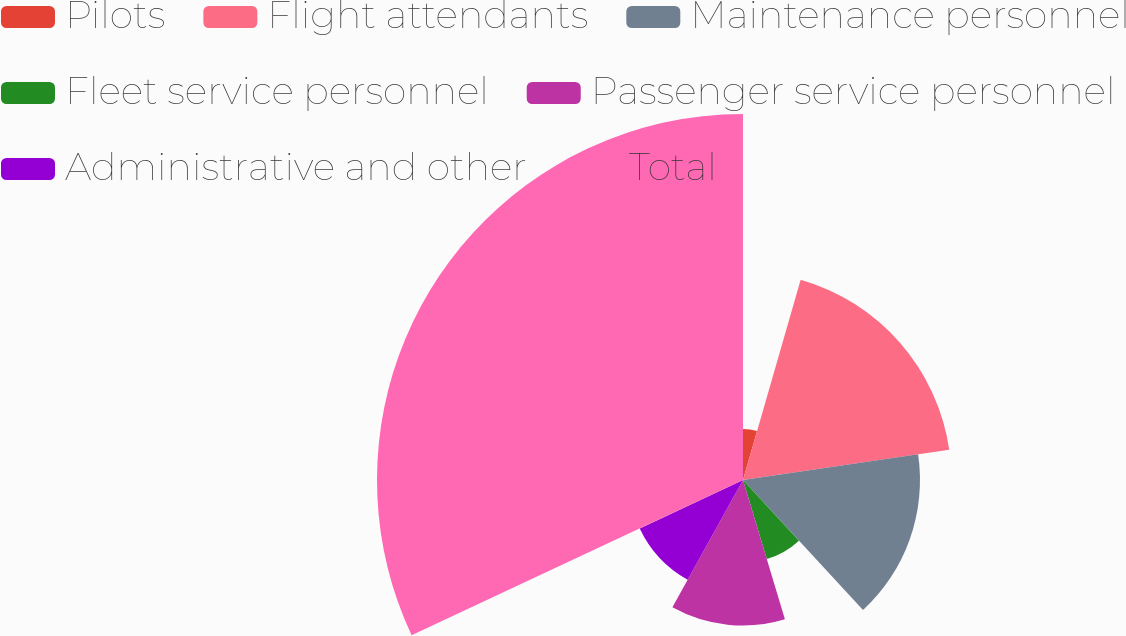Convert chart. <chart><loc_0><loc_0><loc_500><loc_500><pie_chart><fcel>Pilots<fcel>Flight attendants<fcel>Maintenance personnel<fcel>Fleet service personnel<fcel>Passenger service personnel<fcel>Administrative and other<fcel>Total<nl><fcel>4.46%<fcel>18.21%<fcel>15.46%<fcel>7.21%<fcel>12.71%<fcel>9.96%<fcel>31.97%<nl></chart> 